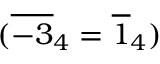Convert formula to latex. <formula><loc_0><loc_0><loc_500><loc_500>( \overline { - 3 } _ { 4 } = \overline { 1 } _ { 4 } )</formula> 